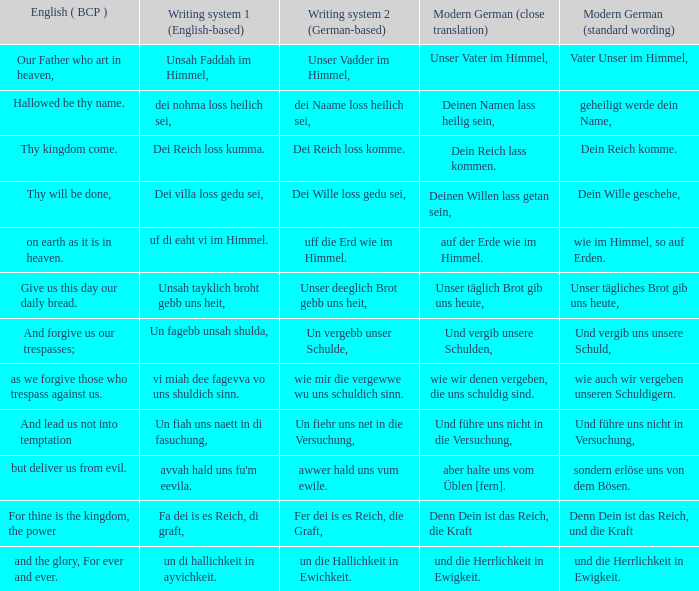What is the english (bcp) saying "for thine is the kingdom, the power" in up-to-date german with typical wording? Denn Dein ist das Reich, und die Kraft. 